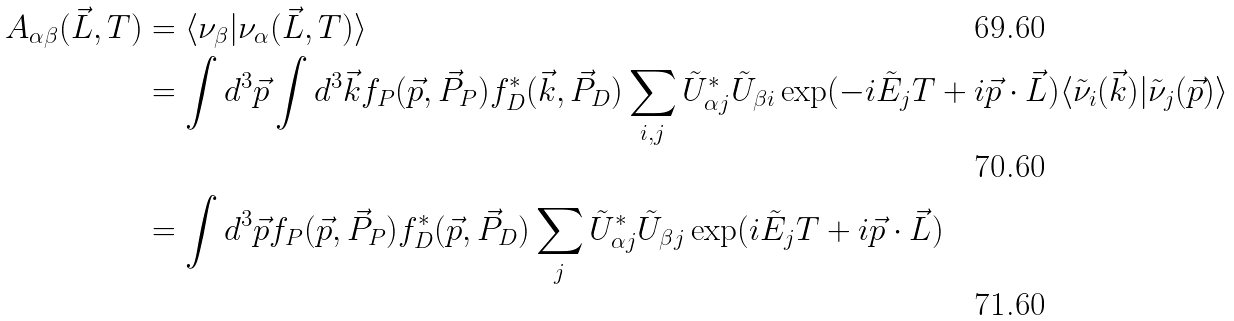Convert formula to latex. <formula><loc_0><loc_0><loc_500><loc_500>A _ { \alpha \beta } ( \vec { L } , T ) & = \langle \nu _ { \beta } | \nu _ { \alpha } ( \vec { L } , T ) \rangle \\ & = \int d ^ { 3 } \vec { p } \int d ^ { 3 } \vec { k } f _ { P } ( \vec { p } , \vec { P } _ { P } ) f _ { D } ^ { \ast } ( \vec { k } , \vec { P } _ { D } ) \sum _ { i , j } \tilde { U } _ { \alpha j } ^ { \ast } \tilde { U } _ { \beta i } \exp ( - i \tilde { E } _ { j } T + i \vec { p } \cdot \vec { L } ) \langle \tilde { \nu } _ { i } ( \vec { k } ) | \tilde { \nu } _ { j } ( \vec { p } ) \rangle \\ & = \int d ^ { 3 } \vec { p } f _ { P } ( \vec { p } , \vec { P } _ { P } ) f ^ { \ast } _ { D } ( \vec { p } , \vec { P } _ { D } ) \sum _ { j } \tilde { U } _ { \alpha j } ^ { \ast } \tilde { U } _ { \beta j } \exp ( i \tilde { E } _ { j } T + i \vec { p } \cdot \vec { L } )</formula> 